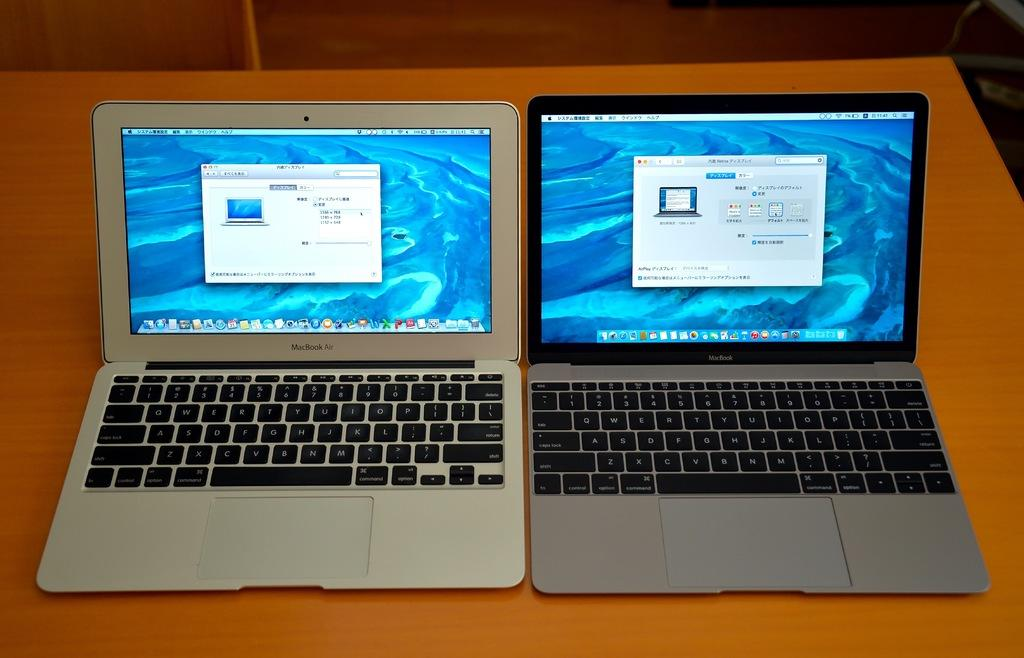<image>
Offer a succinct explanation of the picture presented. Two laptop computers sitting side by side with the one of the left having a screen display setting of 1366 x 768. 